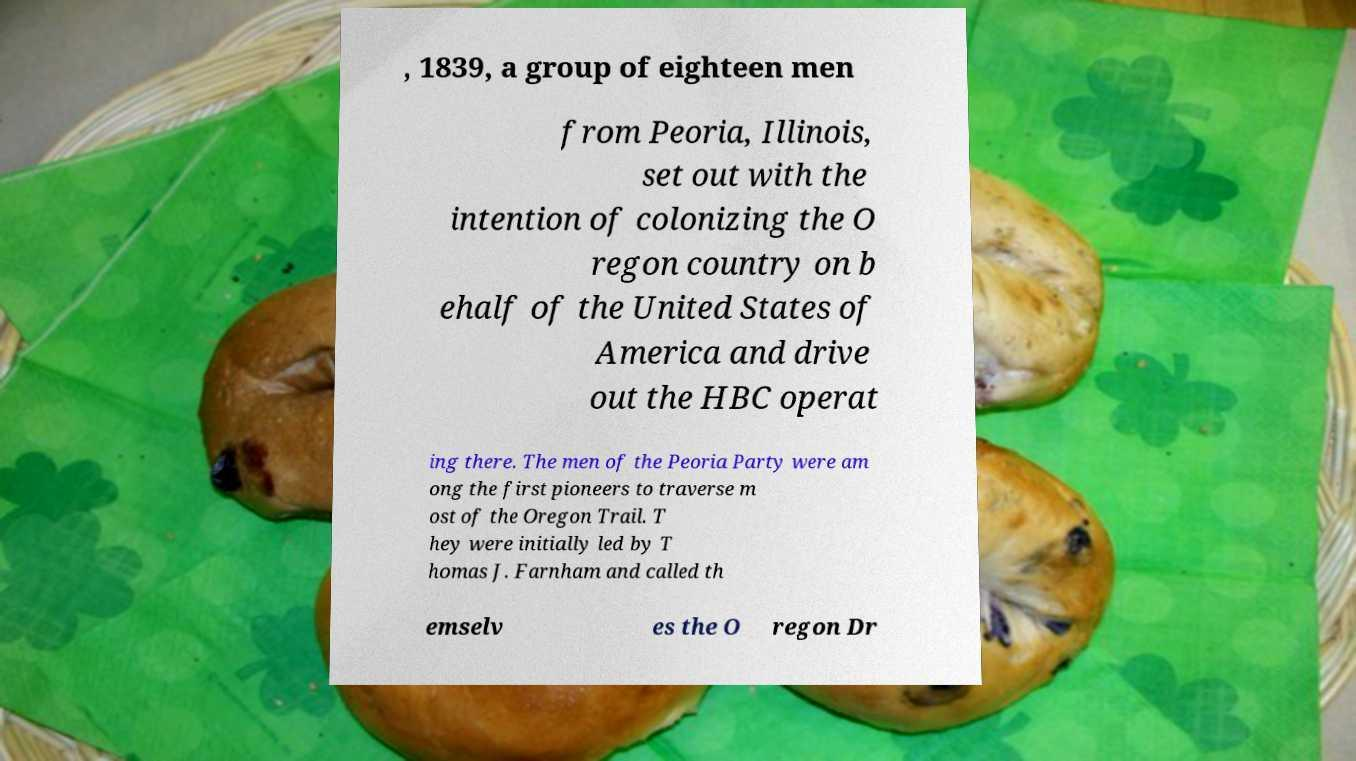Please identify and transcribe the text found in this image. , 1839, a group of eighteen men from Peoria, Illinois, set out with the intention of colonizing the O regon country on b ehalf of the United States of America and drive out the HBC operat ing there. The men of the Peoria Party were am ong the first pioneers to traverse m ost of the Oregon Trail. T hey were initially led by T homas J. Farnham and called th emselv es the O regon Dr 